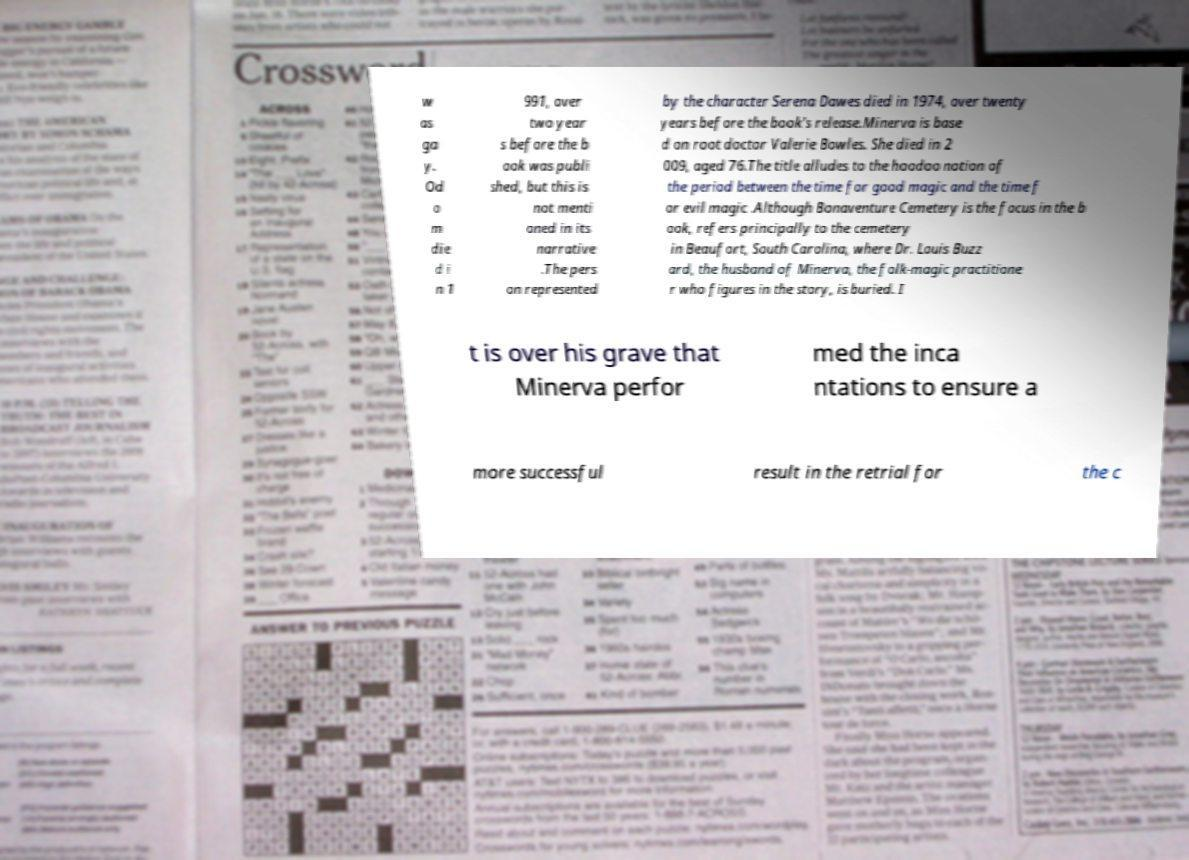Could you extract and type out the text from this image? w as ga y. Od o m die d i n 1 991, over two year s before the b ook was publi shed, but this is not menti oned in its narrative .The pers on represented by the character Serena Dawes died in 1974, over twenty years before the book's release.Minerva is base d on root doctor Valerie Bowles. She died in 2 009, aged 76.The title alludes to the hoodoo notion of the period between the time for good magic and the time f or evil magic .Although Bonaventure Cemetery is the focus in the b ook, refers principally to the cemetery in Beaufort, South Carolina, where Dr. Louis Buzz ard, the husband of Minerva, the folk-magic practitione r who figures in the story, is buried. I t is over his grave that Minerva perfor med the inca ntations to ensure a more successful result in the retrial for the c 